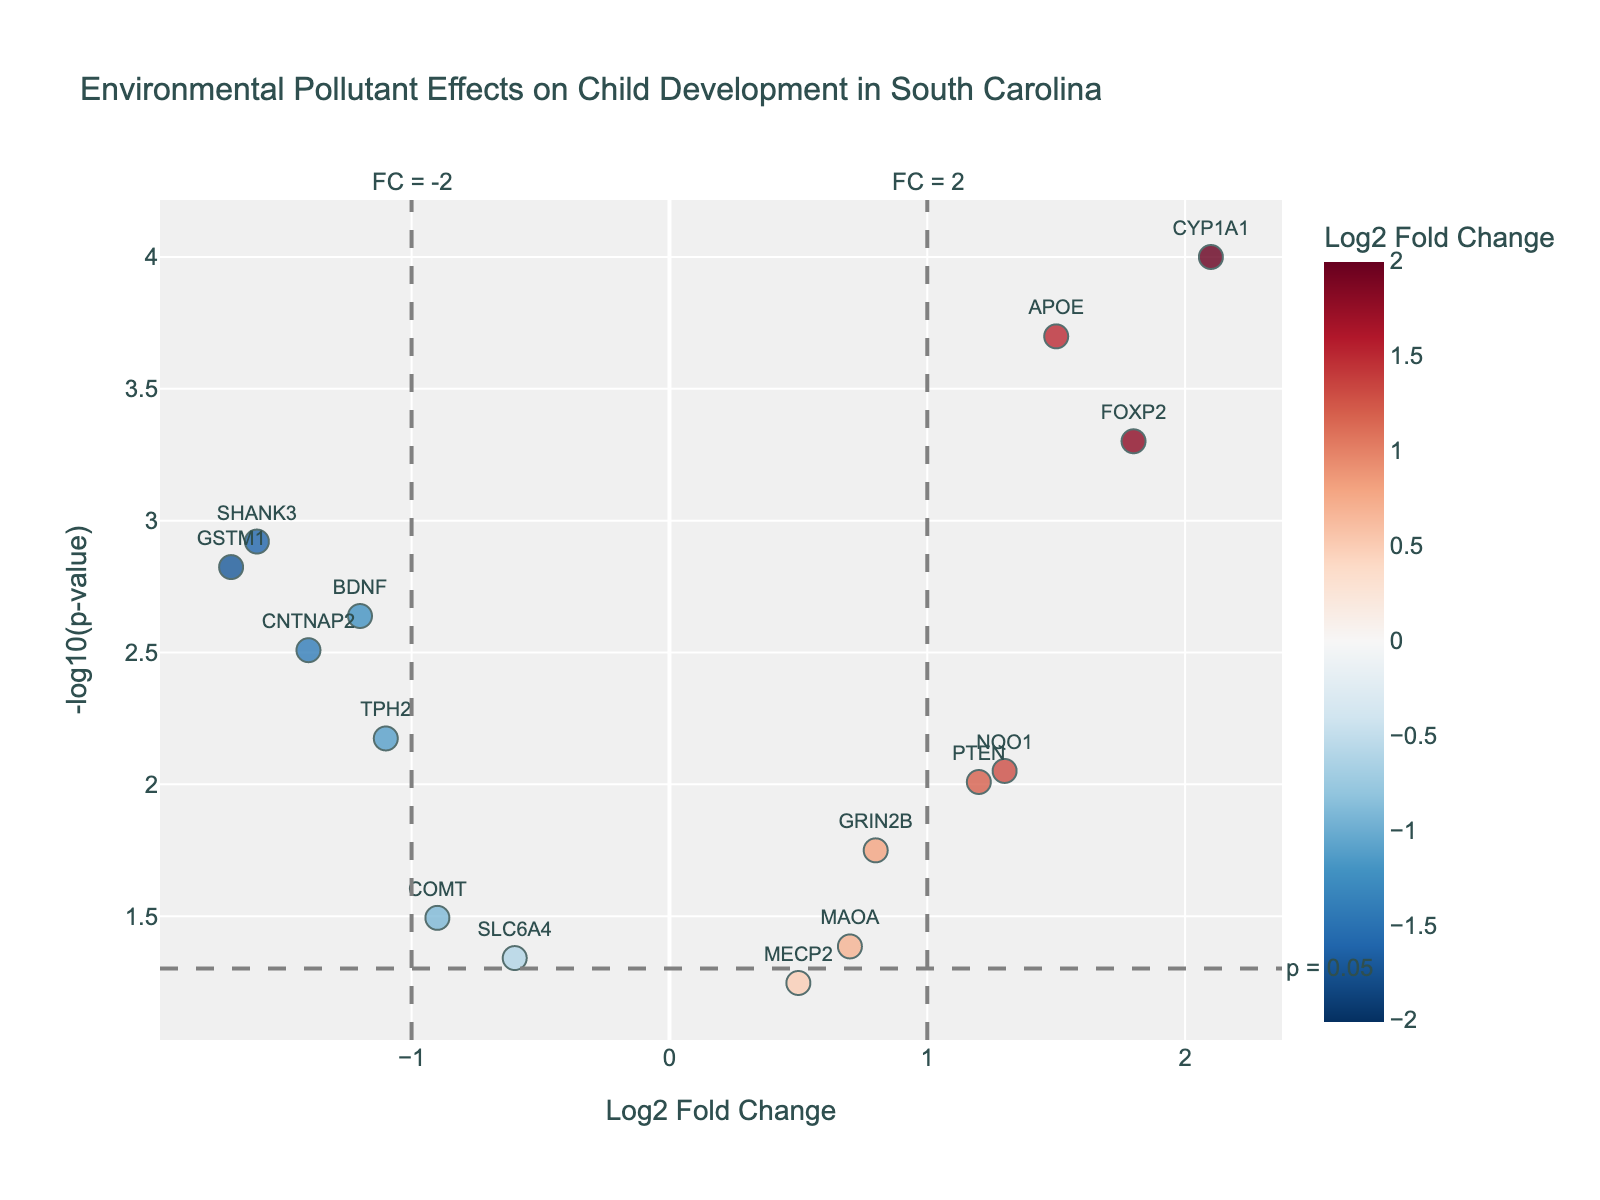What is the title of the figure? The title of the figure is located at the top and is visually distinct, typically in a larger and bold font size.
Answer: Environmental Pollutant Effects on Child Development in South Carolina How many genes are shown in the plot? To find the number of genes, count the distinct points shown in the scatter plot. Each point represents a gene. There are 15 distinct points.
Answer: 15 Which gene has the highest -log10(p-value)? The highest -log10(p-value) can be found by identifying the point with the greatest y-value. CYP1A1 is the highest.
Answer: CYP1A1 Which gene has the most significant negative Log2 Fold Change? Identify the point with the lowest x-value (most negative). GSTM1 has the highest significance with -1.7.
Answer: GSTM1 Are there any genes with a Log2 Fold Change close to zero? Check for points around the middle of the x-axis (close to zero). MECP2 is closest with a Log2 Fold Change of 0.5.
Answer: MECP2 How many genes have p-values below 0.05? Identify points that are above the horizontal threshold line marked p = 0.05. There are 13 such points.
Answer: 13 Which gene shows the largest positive Log2 Fold Change and is highly significant? Look for the point with the highest positive x-value and significant y-value. CYP1A1 has the largest positive Log2 Fold Change.
Answer: CYP1A1 Which gene has a Log2 Fold Change of less than -1 and a highly significant p-value? Identify the point to the left of -1 on the x-axis and above the horizontal threshold line. CNTNAP2 fits this criteria.
Answer: CNTNAP2 Are there any genes with highly significant p-values but modest fold changes? Points above the p = 0.05 line but close to the center on the x-axis indicate this condition. BDNF is one such gene with a modest fold change around -1.2.
Answer: BDNF 